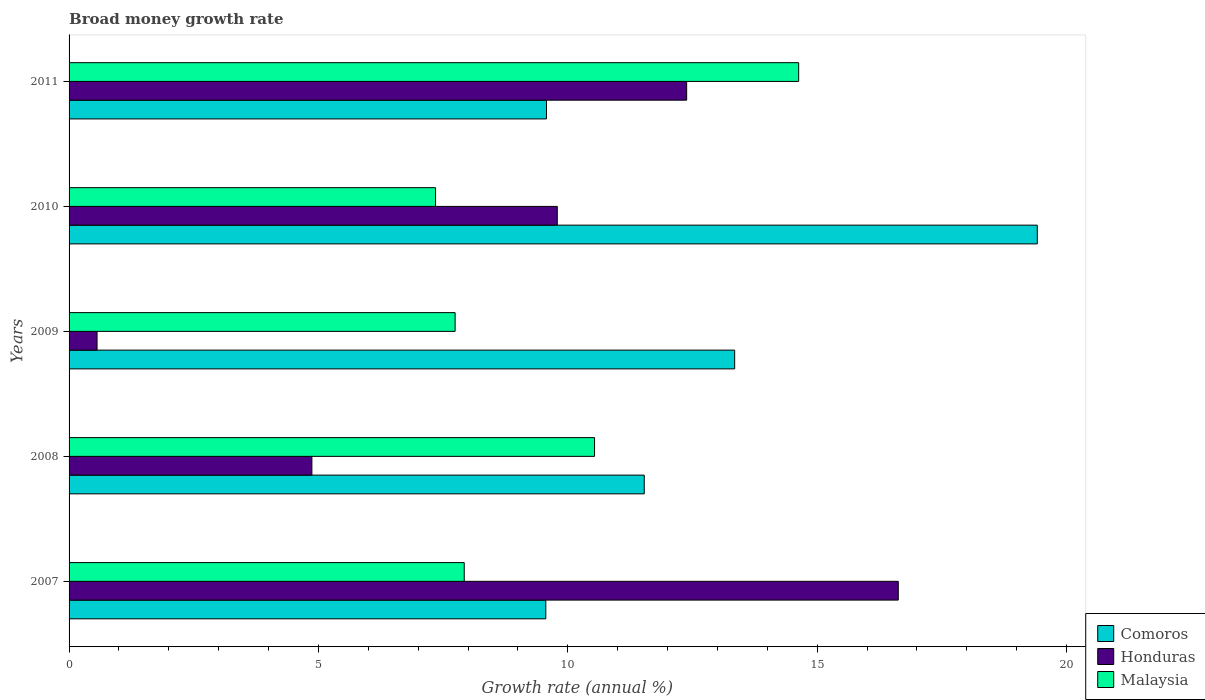How many different coloured bars are there?
Offer a very short reply. 3. How many groups of bars are there?
Offer a terse response. 5. Are the number of bars per tick equal to the number of legend labels?
Your answer should be compact. Yes. Are the number of bars on each tick of the Y-axis equal?
Your answer should be very brief. Yes. How many bars are there on the 1st tick from the top?
Ensure brevity in your answer.  3. In how many cases, is the number of bars for a given year not equal to the number of legend labels?
Your answer should be very brief. 0. What is the growth rate in Malaysia in 2009?
Offer a terse response. 7.74. Across all years, what is the maximum growth rate in Honduras?
Give a very brief answer. 16.62. Across all years, what is the minimum growth rate in Honduras?
Your response must be concise. 0.56. What is the total growth rate in Comoros in the graph?
Give a very brief answer. 63.42. What is the difference between the growth rate in Honduras in 2009 and that in 2010?
Offer a very short reply. -9.23. What is the difference between the growth rate in Honduras in 2011 and the growth rate in Comoros in 2008?
Your answer should be very brief. 0.85. What is the average growth rate in Honduras per year?
Offer a terse response. 8.84. In the year 2009, what is the difference between the growth rate in Malaysia and growth rate in Comoros?
Give a very brief answer. -5.6. What is the ratio of the growth rate in Malaysia in 2007 to that in 2008?
Provide a short and direct response. 0.75. Is the growth rate in Comoros in 2007 less than that in 2008?
Your answer should be compact. Yes. Is the difference between the growth rate in Malaysia in 2010 and 2011 greater than the difference between the growth rate in Comoros in 2010 and 2011?
Provide a succinct answer. No. What is the difference between the highest and the second highest growth rate in Malaysia?
Keep it short and to the point. 4.09. What is the difference between the highest and the lowest growth rate in Malaysia?
Provide a succinct answer. 7.28. Is the sum of the growth rate in Comoros in 2007 and 2009 greater than the maximum growth rate in Honduras across all years?
Your response must be concise. Yes. What does the 1st bar from the top in 2011 represents?
Your answer should be compact. Malaysia. What does the 1st bar from the bottom in 2009 represents?
Keep it short and to the point. Comoros. How many bars are there?
Ensure brevity in your answer.  15. Are all the bars in the graph horizontal?
Your answer should be compact. Yes. What is the difference between two consecutive major ticks on the X-axis?
Your answer should be very brief. 5. Are the values on the major ticks of X-axis written in scientific E-notation?
Ensure brevity in your answer.  No. How are the legend labels stacked?
Your answer should be compact. Vertical. What is the title of the graph?
Provide a short and direct response. Broad money growth rate. Does "Arab World" appear as one of the legend labels in the graph?
Make the answer very short. No. What is the label or title of the X-axis?
Offer a terse response. Growth rate (annual %). What is the Growth rate (annual %) of Comoros in 2007?
Provide a short and direct response. 9.56. What is the Growth rate (annual %) of Honduras in 2007?
Provide a short and direct response. 16.62. What is the Growth rate (annual %) in Malaysia in 2007?
Your answer should be very brief. 7.92. What is the Growth rate (annual %) of Comoros in 2008?
Your answer should be very brief. 11.53. What is the Growth rate (annual %) in Honduras in 2008?
Provide a short and direct response. 4.87. What is the Growth rate (annual %) in Malaysia in 2008?
Make the answer very short. 10.54. What is the Growth rate (annual %) in Comoros in 2009?
Offer a terse response. 13.34. What is the Growth rate (annual %) of Honduras in 2009?
Your response must be concise. 0.56. What is the Growth rate (annual %) in Malaysia in 2009?
Keep it short and to the point. 7.74. What is the Growth rate (annual %) of Comoros in 2010?
Ensure brevity in your answer.  19.41. What is the Growth rate (annual %) in Honduras in 2010?
Your answer should be compact. 9.79. What is the Growth rate (annual %) of Malaysia in 2010?
Give a very brief answer. 7.35. What is the Growth rate (annual %) of Comoros in 2011?
Offer a very short reply. 9.57. What is the Growth rate (annual %) of Honduras in 2011?
Provide a short and direct response. 12.38. What is the Growth rate (annual %) in Malaysia in 2011?
Keep it short and to the point. 14.63. Across all years, what is the maximum Growth rate (annual %) of Comoros?
Offer a very short reply. 19.41. Across all years, what is the maximum Growth rate (annual %) in Honduras?
Your answer should be very brief. 16.62. Across all years, what is the maximum Growth rate (annual %) of Malaysia?
Your answer should be very brief. 14.63. Across all years, what is the minimum Growth rate (annual %) of Comoros?
Provide a short and direct response. 9.56. Across all years, what is the minimum Growth rate (annual %) in Honduras?
Your answer should be very brief. 0.56. Across all years, what is the minimum Growth rate (annual %) of Malaysia?
Offer a terse response. 7.35. What is the total Growth rate (annual %) in Comoros in the graph?
Your answer should be very brief. 63.42. What is the total Growth rate (annual %) of Honduras in the graph?
Your response must be concise. 44.22. What is the total Growth rate (annual %) of Malaysia in the graph?
Give a very brief answer. 48.17. What is the difference between the Growth rate (annual %) in Comoros in 2007 and that in 2008?
Your answer should be very brief. -1.97. What is the difference between the Growth rate (annual %) of Honduras in 2007 and that in 2008?
Your answer should be very brief. 11.76. What is the difference between the Growth rate (annual %) of Malaysia in 2007 and that in 2008?
Offer a terse response. -2.61. What is the difference between the Growth rate (annual %) in Comoros in 2007 and that in 2009?
Keep it short and to the point. -3.79. What is the difference between the Growth rate (annual %) in Honduras in 2007 and that in 2009?
Your answer should be very brief. 16.06. What is the difference between the Growth rate (annual %) of Malaysia in 2007 and that in 2009?
Give a very brief answer. 0.18. What is the difference between the Growth rate (annual %) of Comoros in 2007 and that in 2010?
Offer a terse response. -9.85. What is the difference between the Growth rate (annual %) of Honduras in 2007 and that in 2010?
Make the answer very short. 6.84. What is the difference between the Growth rate (annual %) of Malaysia in 2007 and that in 2010?
Give a very brief answer. 0.57. What is the difference between the Growth rate (annual %) in Comoros in 2007 and that in 2011?
Your answer should be very brief. -0.01. What is the difference between the Growth rate (annual %) in Honduras in 2007 and that in 2011?
Provide a short and direct response. 4.24. What is the difference between the Growth rate (annual %) in Malaysia in 2007 and that in 2011?
Your response must be concise. -6.71. What is the difference between the Growth rate (annual %) in Comoros in 2008 and that in 2009?
Make the answer very short. -1.81. What is the difference between the Growth rate (annual %) of Honduras in 2008 and that in 2009?
Keep it short and to the point. 4.31. What is the difference between the Growth rate (annual %) of Malaysia in 2008 and that in 2009?
Your answer should be very brief. 2.8. What is the difference between the Growth rate (annual %) of Comoros in 2008 and that in 2010?
Keep it short and to the point. -7.88. What is the difference between the Growth rate (annual %) of Honduras in 2008 and that in 2010?
Offer a very short reply. -4.92. What is the difference between the Growth rate (annual %) of Malaysia in 2008 and that in 2010?
Your answer should be very brief. 3.19. What is the difference between the Growth rate (annual %) of Comoros in 2008 and that in 2011?
Offer a very short reply. 1.96. What is the difference between the Growth rate (annual %) in Honduras in 2008 and that in 2011?
Your response must be concise. -7.51. What is the difference between the Growth rate (annual %) of Malaysia in 2008 and that in 2011?
Your response must be concise. -4.09. What is the difference between the Growth rate (annual %) in Comoros in 2009 and that in 2010?
Ensure brevity in your answer.  -6.07. What is the difference between the Growth rate (annual %) of Honduras in 2009 and that in 2010?
Give a very brief answer. -9.23. What is the difference between the Growth rate (annual %) in Malaysia in 2009 and that in 2010?
Offer a very short reply. 0.39. What is the difference between the Growth rate (annual %) in Comoros in 2009 and that in 2011?
Your response must be concise. 3.77. What is the difference between the Growth rate (annual %) of Honduras in 2009 and that in 2011?
Your answer should be very brief. -11.82. What is the difference between the Growth rate (annual %) in Malaysia in 2009 and that in 2011?
Your answer should be very brief. -6.89. What is the difference between the Growth rate (annual %) of Comoros in 2010 and that in 2011?
Keep it short and to the point. 9.84. What is the difference between the Growth rate (annual %) in Honduras in 2010 and that in 2011?
Your answer should be very brief. -2.59. What is the difference between the Growth rate (annual %) in Malaysia in 2010 and that in 2011?
Keep it short and to the point. -7.28. What is the difference between the Growth rate (annual %) in Comoros in 2007 and the Growth rate (annual %) in Honduras in 2008?
Keep it short and to the point. 4.69. What is the difference between the Growth rate (annual %) of Comoros in 2007 and the Growth rate (annual %) of Malaysia in 2008?
Ensure brevity in your answer.  -0.98. What is the difference between the Growth rate (annual %) in Honduras in 2007 and the Growth rate (annual %) in Malaysia in 2008?
Your answer should be very brief. 6.09. What is the difference between the Growth rate (annual %) in Comoros in 2007 and the Growth rate (annual %) in Honduras in 2009?
Your answer should be compact. 9. What is the difference between the Growth rate (annual %) in Comoros in 2007 and the Growth rate (annual %) in Malaysia in 2009?
Your answer should be compact. 1.82. What is the difference between the Growth rate (annual %) of Honduras in 2007 and the Growth rate (annual %) of Malaysia in 2009?
Provide a succinct answer. 8.88. What is the difference between the Growth rate (annual %) of Comoros in 2007 and the Growth rate (annual %) of Honduras in 2010?
Keep it short and to the point. -0.23. What is the difference between the Growth rate (annual %) of Comoros in 2007 and the Growth rate (annual %) of Malaysia in 2010?
Make the answer very short. 2.21. What is the difference between the Growth rate (annual %) in Honduras in 2007 and the Growth rate (annual %) in Malaysia in 2010?
Your response must be concise. 9.28. What is the difference between the Growth rate (annual %) in Comoros in 2007 and the Growth rate (annual %) in Honduras in 2011?
Your response must be concise. -2.82. What is the difference between the Growth rate (annual %) in Comoros in 2007 and the Growth rate (annual %) in Malaysia in 2011?
Give a very brief answer. -5.07. What is the difference between the Growth rate (annual %) in Honduras in 2007 and the Growth rate (annual %) in Malaysia in 2011?
Make the answer very short. 2. What is the difference between the Growth rate (annual %) of Comoros in 2008 and the Growth rate (annual %) of Honduras in 2009?
Give a very brief answer. 10.97. What is the difference between the Growth rate (annual %) in Comoros in 2008 and the Growth rate (annual %) in Malaysia in 2009?
Provide a succinct answer. 3.79. What is the difference between the Growth rate (annual %) of Honduras in 2008 and the Growth rate (annual %) of Malaysia in 2009?
Provide a short and direct response. -2.87. What is the difference between the Growth rate (annual %) in Comoros in 2008 and the Growth rate (annual %) in Honduras in 2010?
Ensure brevity in your answer.  1.74. What is the difference between the Growth rate (annual %) of Comoros in 2008 and the Growth rate (annual %) of Malaysia in 2010?
Your answer should be very brief. 4.18. What is the difference between the Growth rate (annual %) of Honduras in 2008 and the Growth rate (annual %) of Malaysia in 2010?
Provide a short and direct response. -2.48. What is the difference between the Growth rate (annual %) in Comoros in 2008 and the Growth rate (annual %) in Honduras in 2011?
Make the answer very short. -0.85. What is the difference between the Growth rate (annual %) in Comoros in 2008 and the Growth rate (annual %) in Malaysia in 2011?
Provide a succinct answer. -3.1. What is the difference between the Growth rate (annual %) of Honduras in 2008 and the Growth rate (annual %) of Malaysia in 2011?
Make the answer very short. -9.76. What is the difference between the Growth rate (annual %) of Comoros in 2009 and the Growth rate (annual %) of Honduras in 2010?
Your answer should be compact. 3.56. What is the difference between the Growth rate (annual %) in Comoros in 2009 and the Growth rate (annual %) in Malaysia in 2010?
Your answer should be very brief. 6. What is the difference between the Growth rate (annual %) in Honduras in 2009 and the Growth rate (annual %) in Malaysia in 2010?
Offer a very short reply. -6.79. What is the difference between the Growth rate (annual %) of Comoros in 2009 and the Growth rate (annual %) of Honduras in 2011?
Your answer should be very brief. 0.96. What is the difference between the Growth rate (annual %) of Comoros in 2009 and the Growth rate (annual %) of Malaysia in 2011?
Make the answer very short. -1.28. What is the difference between the Growth rate (annual %) in Honduras in 2009 and the Growth rate (annual %) in Malaysia in 2011?
Provide a short and direct response. -14.07. What is the difference between the Growth rate (annual %) of Comoros in 2010 and the Growth rate (annual %) of Honduras in 2011?
Your answer should be compact. 7.03. What is the difference between the Growth rate (annual %) of Comoros in 2010 and the Growth rate (annual %) of Malaysia in 2011?
Provide a succinct answer. 4.78. What is the difference between the Growth rate (annual %) of Honduras in 2010 and the Growth rate (annual %) of Malaysia in 2011?
Provide a succinct answer. -4.84. What is the average Growth rate (annual %) in Comoros per year?
Make the answer very short. 12.68. What is the average Growth rate (annual %) of Honduras per year?
Your answer should be very brief. 8.84. What is the average Growth rate (annual %) in Malaysia per year?
Make the answer very short. 9.63. In the year 2007, what is the difference between the Growth rate (annual %) in Comoros and Growth rate (annual %) in Honduras?
Offer a terse response. -7.07. In the year 2007, what is the difference between the Growth rate (annual %) in Comoros and Growth rate (annual %) in Malaysia?
Offer a terse response. 1.64. In the year 2007, what is the difference between the Growth rate (annual %) of Honduras and Growth rate (annual %) of Malaysia?
Give a very brief answer. 8.7. In the year 2008, what is the difference between the Growth rate (annual %) in Comoros and Growth rate (annual %) in Honduras?
Your response must be concise. 6.66. In the year 2008, what is the difference between the Growth rate (annual %) in Comoros and Growth rate (annual %) in Malaysia?
Keep it short and to the point. 1. In the year 2008, what is the difference between the Growth rate (annual %) in Honduras and Growth rate (annual %) in Malaysia?
Your answer should be very brief. -5.67. In the year 2009, what is the difference between the Growth rate (annual %) of Comoros and Growth rate (annual %) of Honduras?
Your answer should be compact. 12.78. In the year 2009, what is the difference between the Growth rate (annual %) in Comoros and Growth rate (annual %) in Malaysia?
Provide a succinct answer. 5.6. In the year 2009, what is the difference between the Growth rate (annual %) in Honduras and Growth rate (annual %) in Malaysia?
Give a very brief answer. -7.18. In the year 2010, what is the difference between the Growth rate (annual %) in Comoros and Growth rate (annual %) in Honduras?
Provide a short and direct response. 9.62. In the year 2010, what is the difference between the Growth rate (annual %) of Comoros and Growth rate (annual %) of Malaysia?
Your response must be concise. 12.06. In the year 2010, what is the difference between the Growth rate (annual %) of Honduras and Growth rate (annual %) of Malaysia?
Your response must be concise. 2.44. In the year 2011, what is the difference between the Growth rate (annual %) in Comoros and Growth rate (annual %) in Honduras?
Keep it short and to the point. -2.81. In the year 2011, what is the difference between the Growth rate (annual %) of Comoros and Growth rate (annual %) of Malaysia?
Provide a short and direct response. -5.06. In the year 2011, what is the difference between the Growth rate (annual %) of Honduras and Growth rate (annual %) of Malaysia?
Offer a very short reply. -2.25. What is the ratio of the Growth rate (annual %) in Comoros in 2007 to that in 2008?
Your response must be concise. 0.83. What is the ratio of the Growth rate (annual %) of Honduras in 2007 to that in 2008?
Give a very brief answer. 3.41. What is the ratio of the Growth rate (annual %) in Malaysia in 2007 to that in 2008?
Offer a very short reply. 0.75. What is the ratio of the Growth rate (annual %) in Comoros in 2007 to that in 2009?
Your answer should be very brief. 0.72. What is the ratio of the Growth rate (annual %) of Honduras in 2007 to that in 2009?
Make the answer very short. 29.63. What is the ratio of the Growth rate (annual %) in Malaysia in 2007 to that in 2009?
Make the answer very short. 1.02. What is the ratio of the Growth rate (annual %) in Comoros in 2007 to that in 2010?
Offer a very short reply. 0.49. What is the ratio of the Growth rate (annual %) in Honduras in 2007 to that in 2010?
Provide a short and direct response. 1.7. What is the ratio of the Growth rate (annual %) in Malaysia in 2007 to that in 2010?
Keep it short and to the point. 1.08. What is the ratio of the Growth rate (annual %) of Honduras in 2007 to that in 2011?
Provide a short and direct response. 1.34. What is the ratio of the Growth rate (annual %) of Malaysia in 2007 to that in 2011?
Keep it short and to the point. 0.54. What is the ratio of the Growth rate (annual %) of Comoros in 2008 to that in 2009?
Give a very brief answer. 0.86. What is the ratio of the Growth rate (annual %) of Honduras in 2008 to that in 2009?
Your answer should be very brief. 8.68. What is the ratio of the Growth rate (annual %) of Malaysia in 2008 to that in 2009?
Provide a succinct answer. 1.36. What is the ratio of the Growth rate (annual %) in Comoros in 2008 to that in 2010?
Provide a succinct answer. 0.59. What is the ratio of the Growth rate (annual %) of Honduras in 2008 to that in 2010?
Offer a very short reply. 0.5. What is the ratio of the Growth rate (annual %) of Malaysia in 2008 to that in 2010?
Your response must be concise. 1.43. What is the ratio of the Growth rate (annual %) in Comoros in 2008 to that in 2011?
Keep it short and to the point. 1.2. What is the ratio of the Growth rate (annual %) of Honduras in 2008 to that in 2011?
Ensure brevity in your answer.  0.39. What is the ratio of the Growth rate (annual %) of Malaysia in 2008 to that in 2011?
Make the answer very short. 0.72. What is the ratio of the Growth rate (annual %) in Comoros in 2009 to that in 2010?
Provide a short and direct response. 0.69. What is the ratio of the Growth rate (annual %) of Honduras in 2009 to that in 2010?
Your answer should be compact. 0.06. What is the ratio of the Growth rate (annual %) of Malaysia in 2009 to that in 2010?
Offer a terse response. 1.05. What is the ratio of the Growth rate (annual %) in Comoros in 2009 to that in 2011?
Your answer should be compact. 1.39. What is the ratio of the Growth rate (annual %) in Honduras in 2009 to that in 2011?
Provide a short and direct response. 0.05. What is the ratio of the Growth rate (annual %) of Malaysia in 2009 to that in 2011?
Offer a very short reply. 0.53. What is the ratio of the Growth rate (annual %) in Comoros in 2010 to that in 2011?
Your answer should be very brief. 2.03. What is the ratio of the Growth rate (annual %) in Honduras in 2010 to that in 2011?
Your answer should be compact. 0.79. What is the ratio of the Growth rate (annual %) of Malaysia in 2010 to that in 2011?
Offer a very short reply. 0.5. What is the difference between the highest and the second highest Growth rate (annual %) of Comoros?
Ensure brevity in your answer.  6.07. What is the difference between the highest and the second highest Growth rate (annual %) in Honduras?
Make the answer very short. 4.24. What is the difference between the highest and the second highest Growth rate (annual %) in Malaysia?
Provide a succinct answer. 4.09. What is the difference between the highest and the lowest Growth rate (annual %) of Comoros?
Make the answer very short. 9.85. What is the difference between the highest and the lowest Growth rate (annual %) in Honduras?
Give a very brief answer. 16.06. What is the difference between the highest and the lowest Growth rate (annual %) of Malaysia?
Your answer should be very brief. 7.28. 